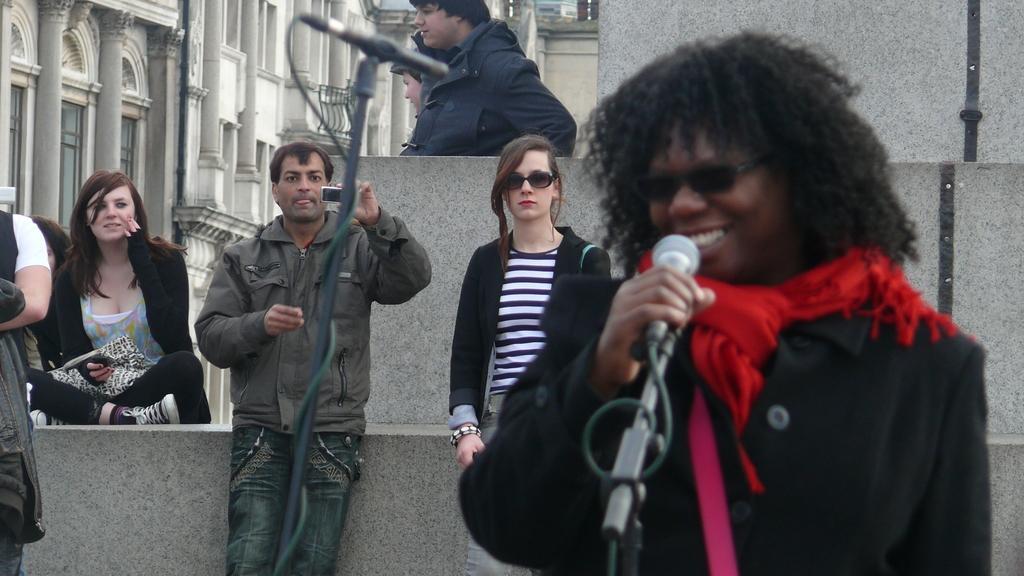Can you describe this image briefly? Here a person is singing on mic behind her there are few people and person is recording on his camera and there is a mic with stand and buildings. 